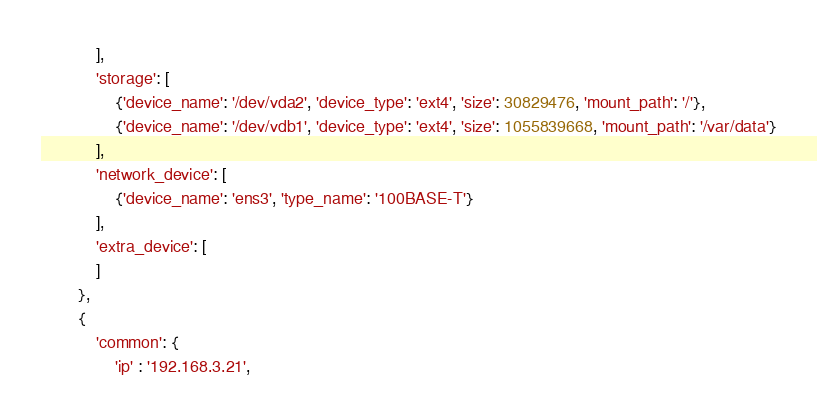Convert code to text. <code><loc_0><loc_0><loc_500><loc_500><_Python_>            ],
            'storage': [
                {'device_name': '/dev/vda2', 'device_type': 'ext4', 'size': 30829476, 'mount_path': '/'},
                {'device_name': '/dev/vdb1', 'device_type': 'ext4', 'size': 1055839668, 'mount_path': '/var/data'}
            ],
            'network_device': [
                {'device_name': 'ens3', 'type_name': '100BASE-T'}
            ],
            'extra_device': [
            ]
        }, 
        {
            'common': {
                'ip' : '192.168.3.21',</code> 